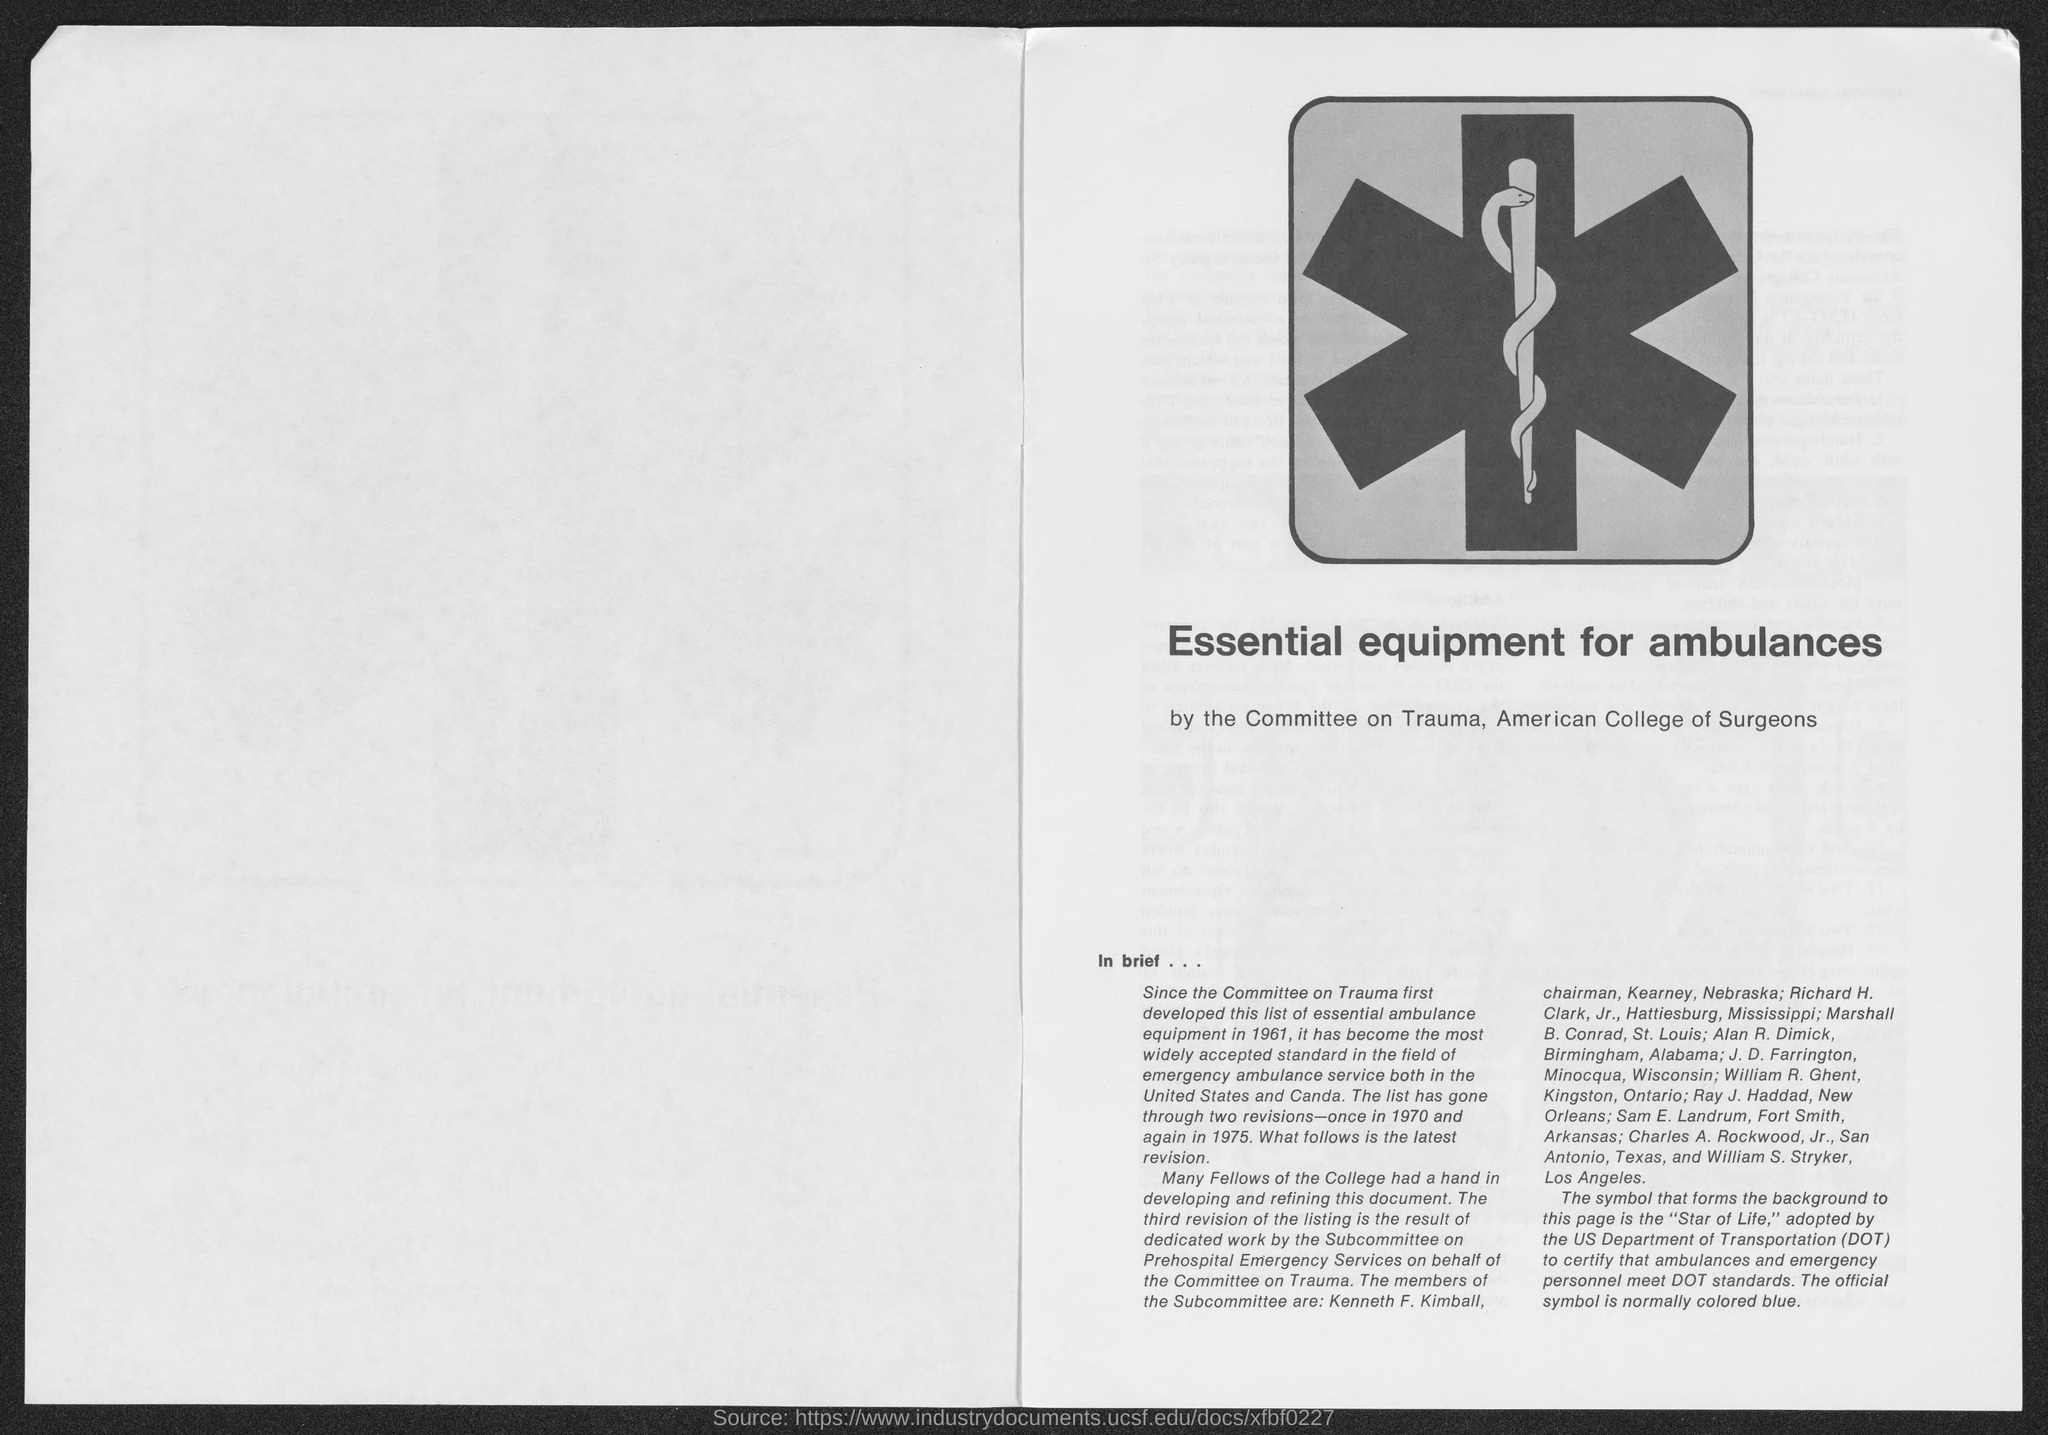Give some essential details in this illustration. The acronym DOT refers to the Department of Transportation. 